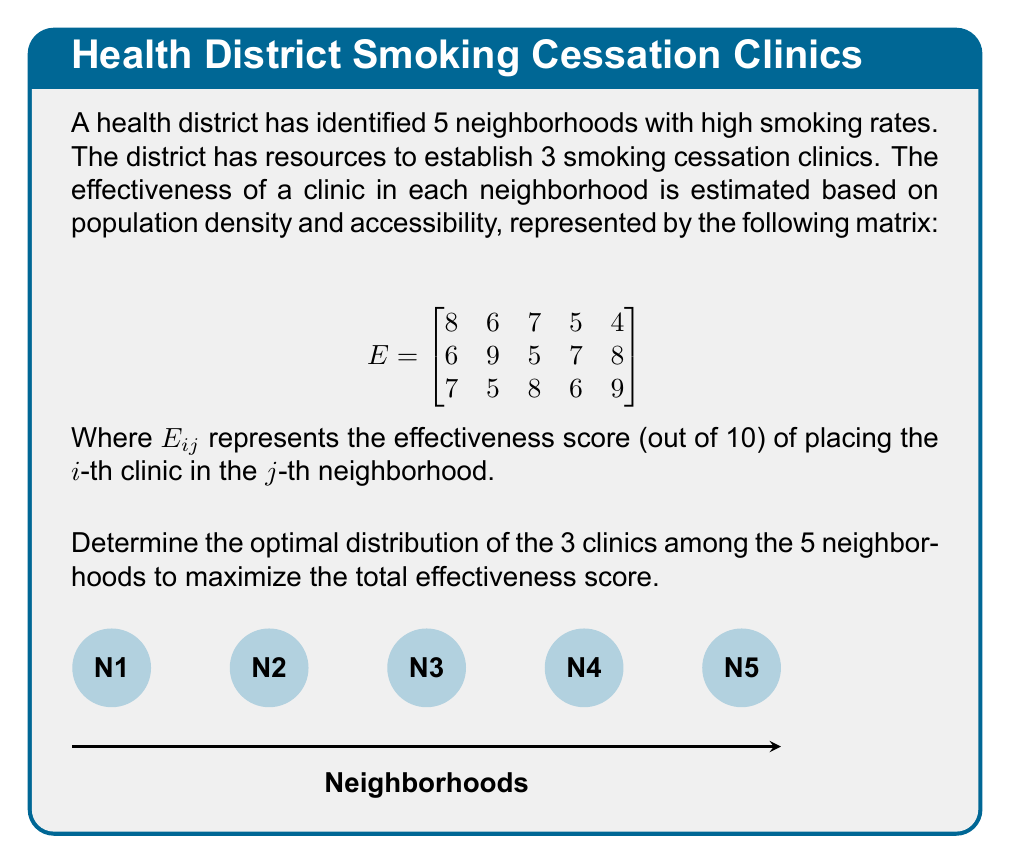What is the answer to this math problem? To solve this optimization problem, we need to find the combination of 3 neighborhoods that yields the highest total effectiveness score. Let's approach this step-by-step:

1) First, we need to calculate the total effectiveness score for all possible combinations of 3 clinics in 5 neighborhoods.

2) The number of combinations is $\binom{5}{3} = 10$.

3) Let's list all possible combinations and calculate their scores:

   (1,2,3): 8 + 9 + 8 = 25
   (1,2,4): 8 + 9 + 6 = 23
   (1,2,5): 8 + 9 + 9 = 26
   (1,3,4): 8 + 5 + 6 = 19
   (1,3,5): 8 + 5 + 9 = 22
   (1,4,5): 8 + 7 + 9 = 24
   (2,3,4): 6 + 8 + 6 = 20
   (2,3,5): 6 + 8 + 9 = 23
   (2,4,5): 6 + 7 + 9 = 22
   (3,4,5): 7 + 7 + 9 = 23

4) The highest score is 26, achieved by placing clinics in neighborhoods 1, 2, and 5.

5) This distribution corresponds to the following effectiveness scores:
   Clinic 1 in Neighborhood 1: 8
   Clinic 2 in Neighborhood 2: 9
   Clinic 3 in Neighborhood 5: 9

6) The total effectiveness score is therefore 8 + 9 + 9 = 26.
Answer: Neighborhoods 1, 2, and 5 